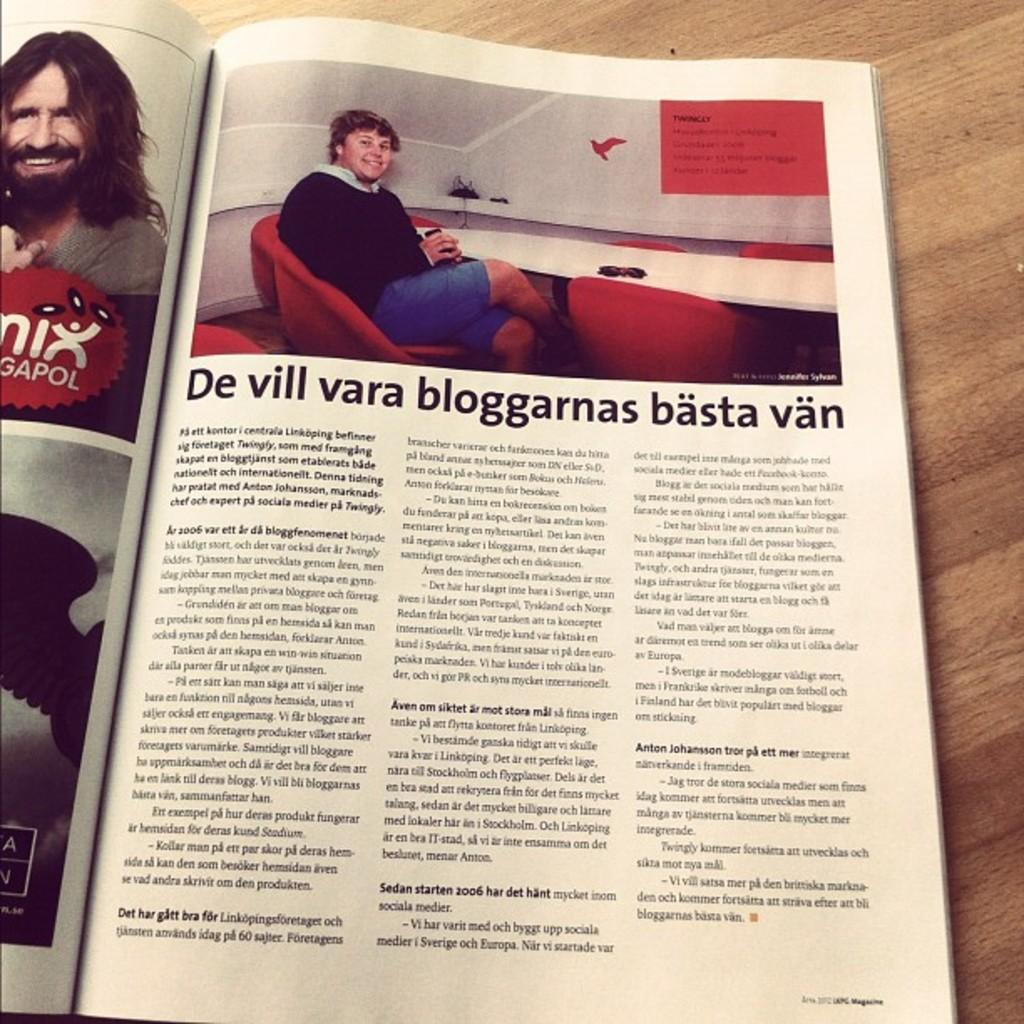What is the main object in the image? There is an open book in the image. What can be found inside the open book? The open book contains text and images of people. What type of surface is visible in the background of the image? There is a wooden surface in the background of the image. What type of bun is being used to join the pages of the book in the image? There is no bun present in the image, nor is there any indication that the pages of the book are being joined together. 